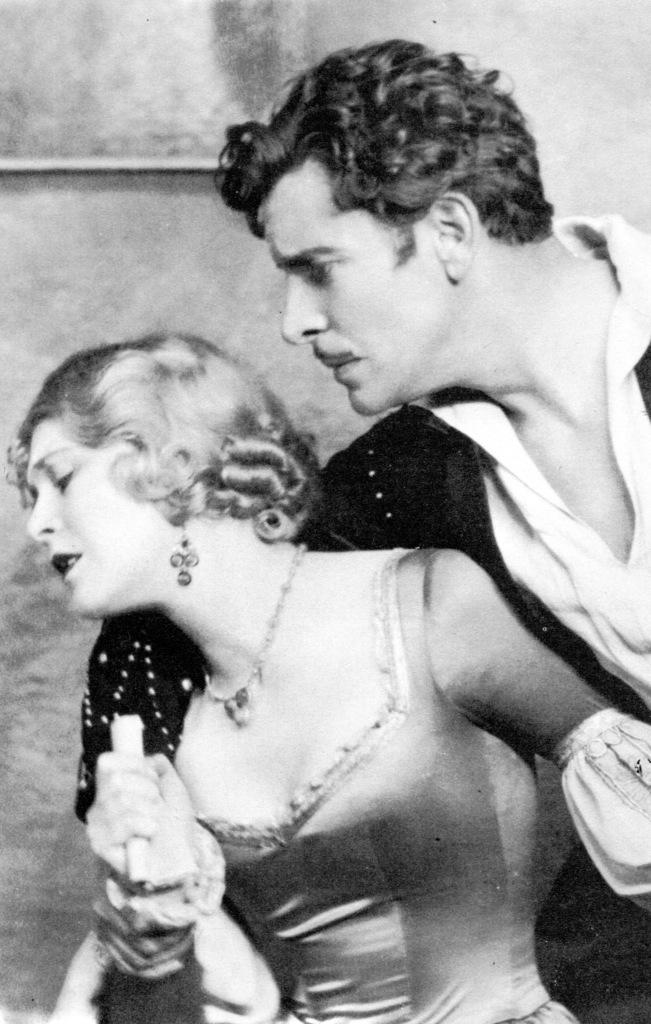How many people are in the image? There is a lady and a man in the image. What is the lady holding in the image? The lady is holding an object. What can be seen in the background of the image? There is a wall in the background of the image. What is the color scheme of the image? The image is in black and white mode. What type of pollution can be seen in the image? There is no pollution present in the image; it is a black and white image of a lady and a man with a wall in the background. 